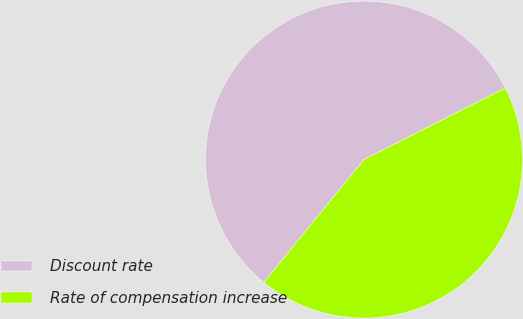Convert chart. <chart><loc_0><loc_0><loc_500><loc_500><pie_chart><fcel>Discount rate<fcel>Rate of compensation increase<nl><fcel>56.65%<fcel>43.35%<nl></chart> 